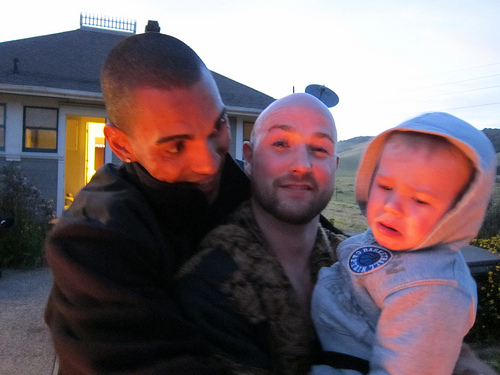<image>
Can you confirm if the baby is to the left of the man? Yes. From this viewpoint, the baby is positioned to the left side relative to the man. Where is the home in relation to the man? Is it next to the man? Yes. The home is positioned adjacent to the man, located nearby in the same general area. 